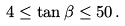Convert formula to latex. <formula><loc_0><loc_0><loc_500><loc_500>4 \leq \tan \beta \leq 5 0 \, .</formula> 